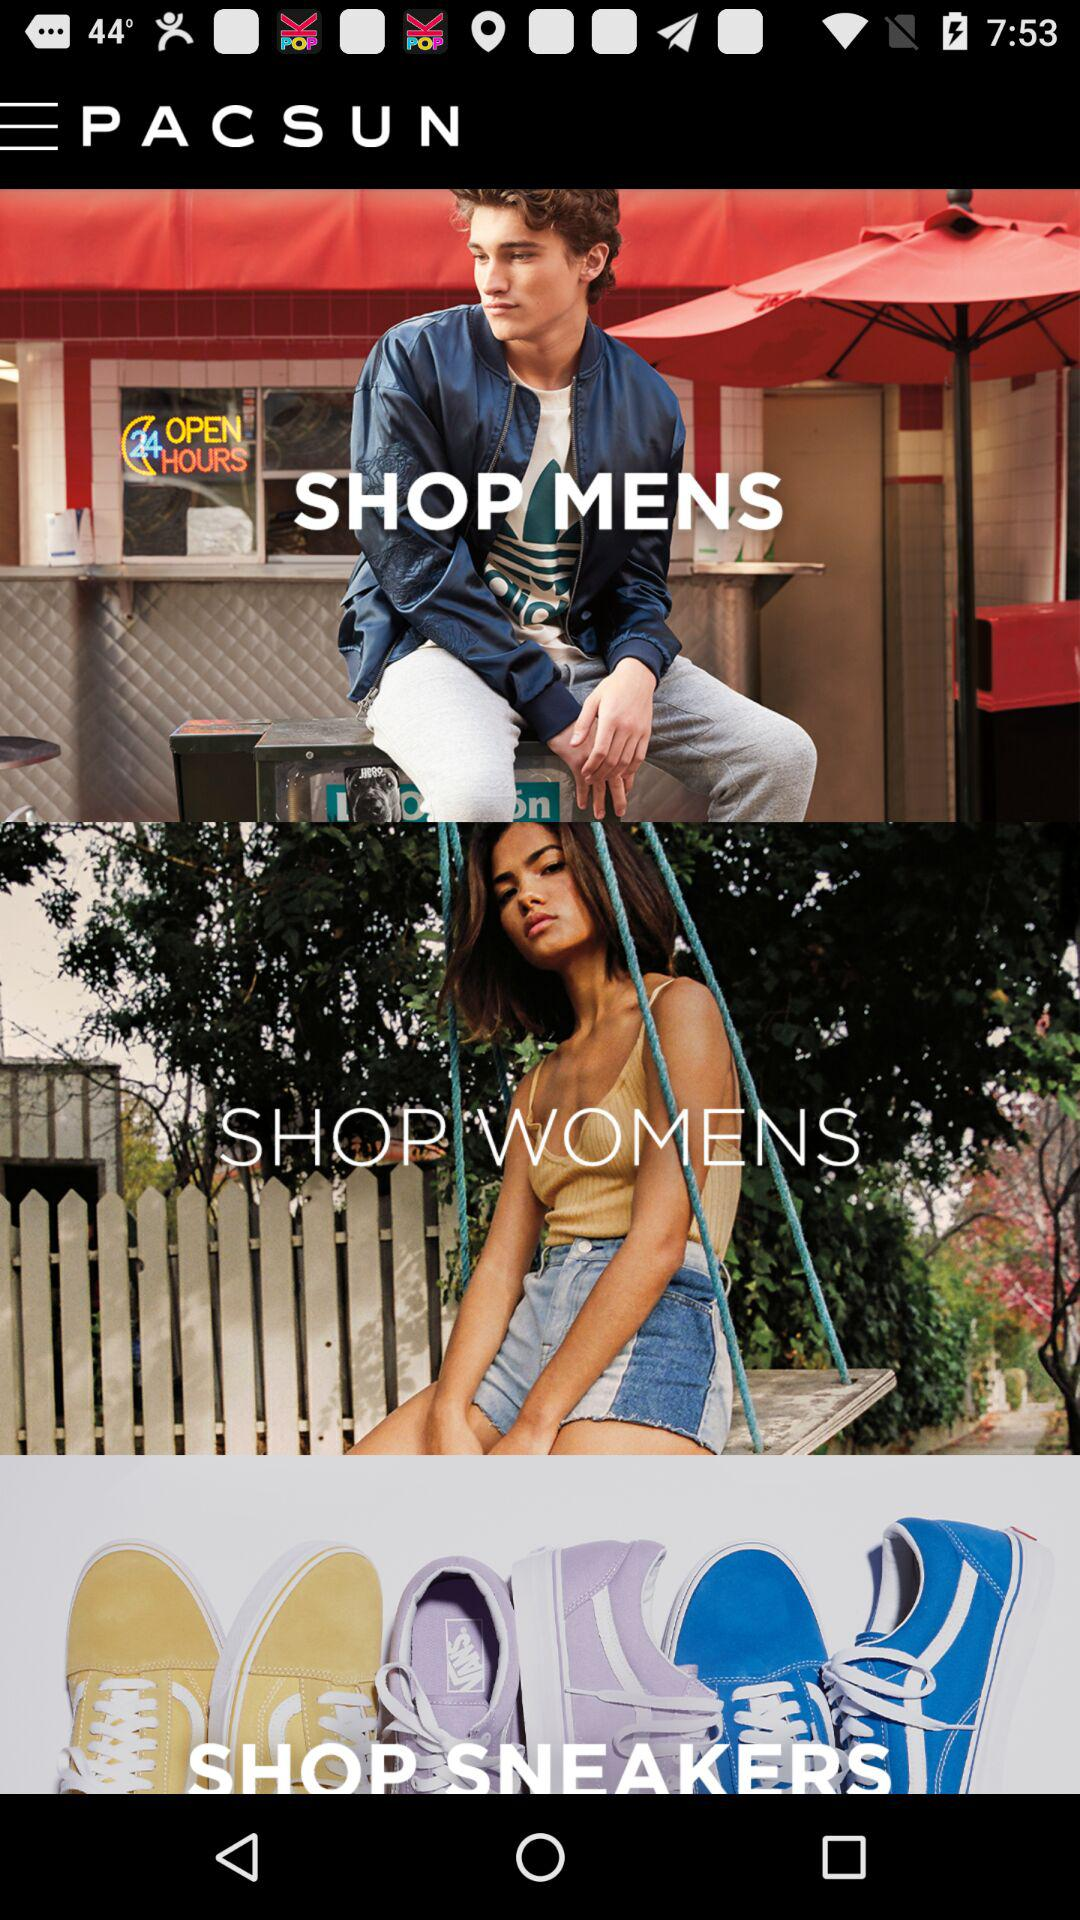Which varieties are given for the shop?
When the provided information is insufficient, respond with <no answer>. <no answer> 